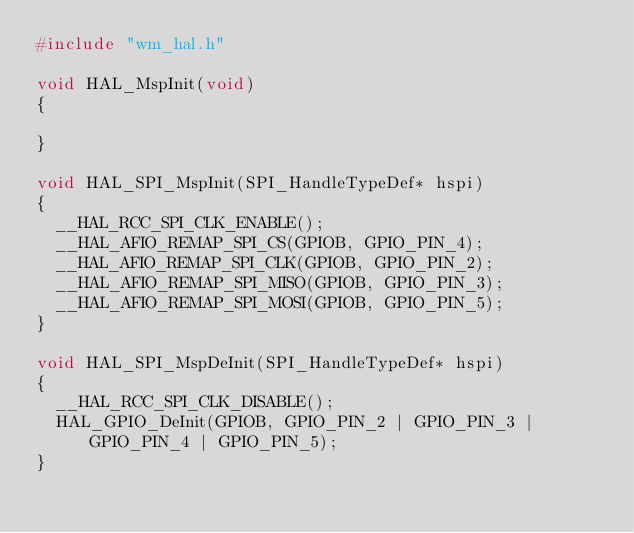<code> <loc_0><loc_0><loc_500><loc_500><_C_>#include "wm_hal.h"

void HAL_MspInit(void)
{

}

void HAL_SPI_MspInit(SPI_HandleTypeDef* hspi)
{
	__HAL_RCC_SPI_CLK_ENABLE();
	__HAL_AFIO_REMAP_SPI_CS(GPIOB, GPIO_PIN_4);
	__HAL_AFIO_REMAP_SPI_CLK(GPIOB, GPIO_PIN_2);
	__HAL_AFIO_REMAP_SPI_MISO(GPIOB, GPIO_PIN_3);
	__HAL_AFIO_REMAP_SPI_MOSI(GPIOB, GPIO_PIN_5);
}

void HAL_SPI_MspDeInit(SPI_HandleTypeDef* hspi)
{
	__HAL_RCC_SPI_CLK_DISABLE();
	HAL_GPIO_DeInit(GPIOB, GPIO_PIN_2 | GPIO_PIN_3 | GPIO_PIN_4 | GPIO_PIN_5);
}

</code> 